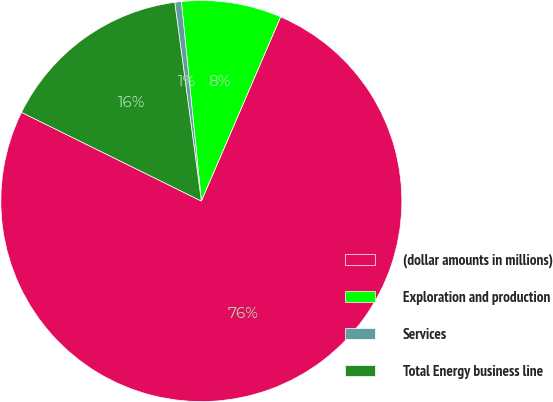Convert chart to OTSL. <chart><loc_0><loc_0><loc_500><loc_500><pie_chart><fcel>(dollar amounts in millions)<fcel>Exploration and production<fcel>Services<fcel>Total Energy business line<nl><fcel>75.83%<fcel>8.06%<fcel>0.53%<fcel>15.59%<nl></chart> 